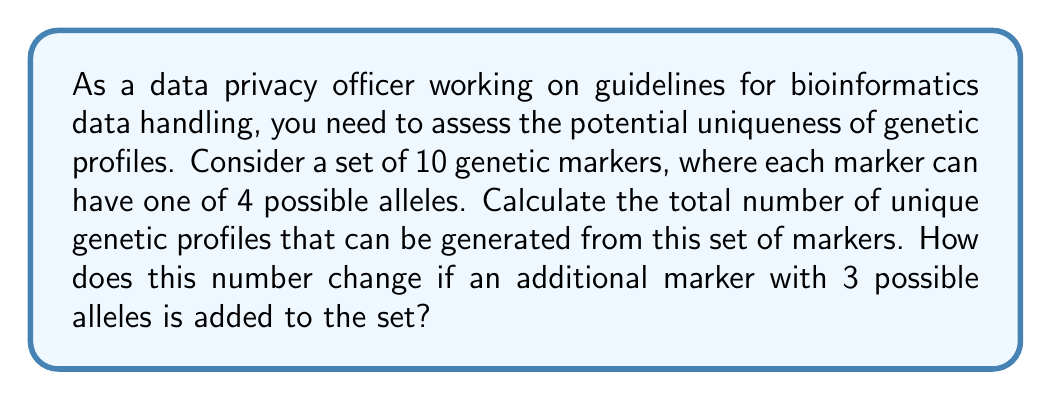Help me with this question. Let's approach this problem step by step:

1) For the initial set of 10 genetic markers:
   - Each marker can have one of 4 possible alleles
   - We need to choose one allele for each marker
   - This is a case of independent choices for each marker

   The total number of possibilities is given by the multiplication principle:
   $$ 4 \times 4 \times 4 \times ... \text{ (10 times) } = 4^{10} $$

2) To calculate $4^{10}$:
   $$ 4^{10} = 1,048,576 $$

3) Now, let's consider adding an additional marker with 3 possible alleles:
   - We now have 11 markers in total
   - 10 markers with 4 alleles each, and 1 marker with 3 alleles

   The new total number of possibilities is:
   $$ 4^{10} \times 3 $$

4) Calculating this new total:
   $$ 1,048,576 \times 3 = 3,145,728 $$

5) The change in the number of unique profiles is:
   $$ 3,145,728 - 1,048,576 = 2,097,152 $$

This significant increase in the number of unique profiles demonstrates how adding even a single genetic marker can greatly enhance the potential for creating unique genetic profiles, which has important implications for data privacy and individual identifiability in bioinformatics datasets.
Answer: The initial number of unique genetic profiles is $4^{10} = 1,048,576$. After adding an additional marker with 3 possible alleles, the number increases to $4^{10} \times 3 = 3,145,728$, a difference of 2,097,152 profiles. 